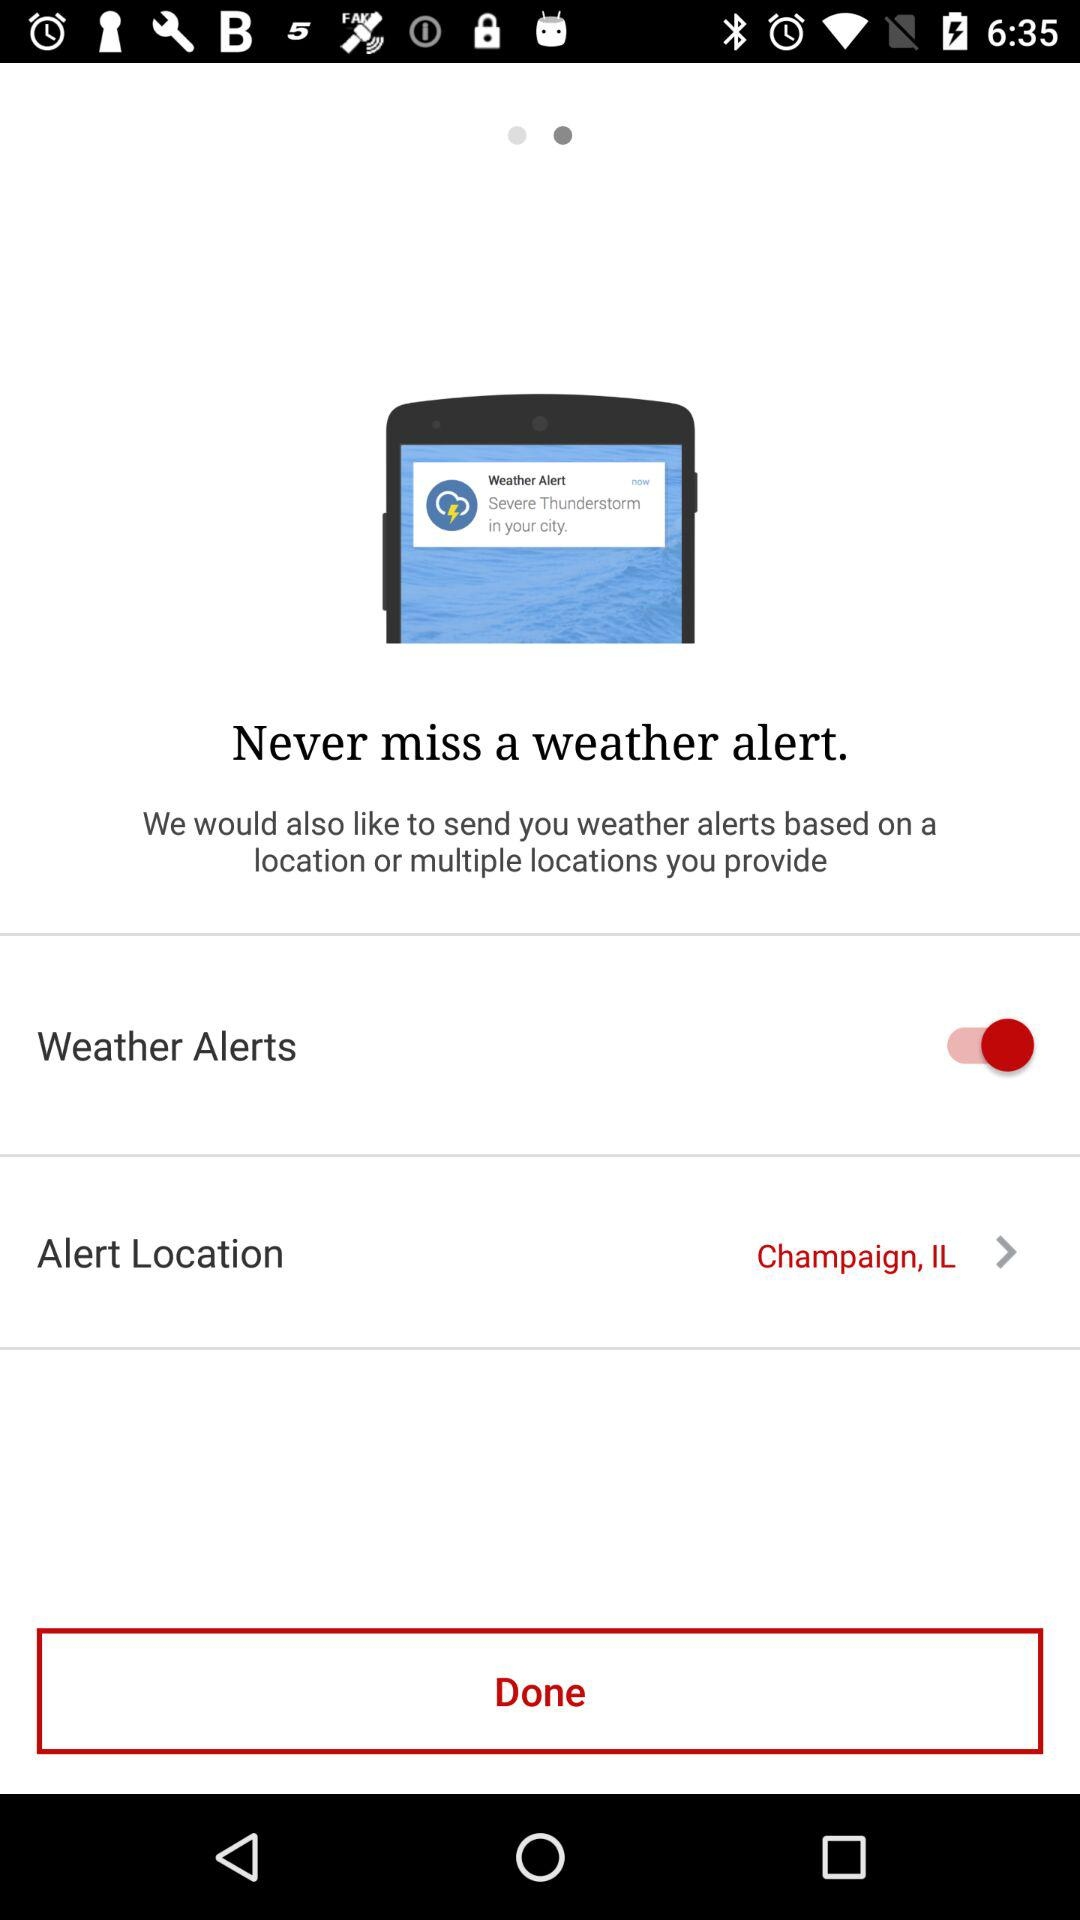Which option has been enabled? The enabled option is "Weather Alerts". 